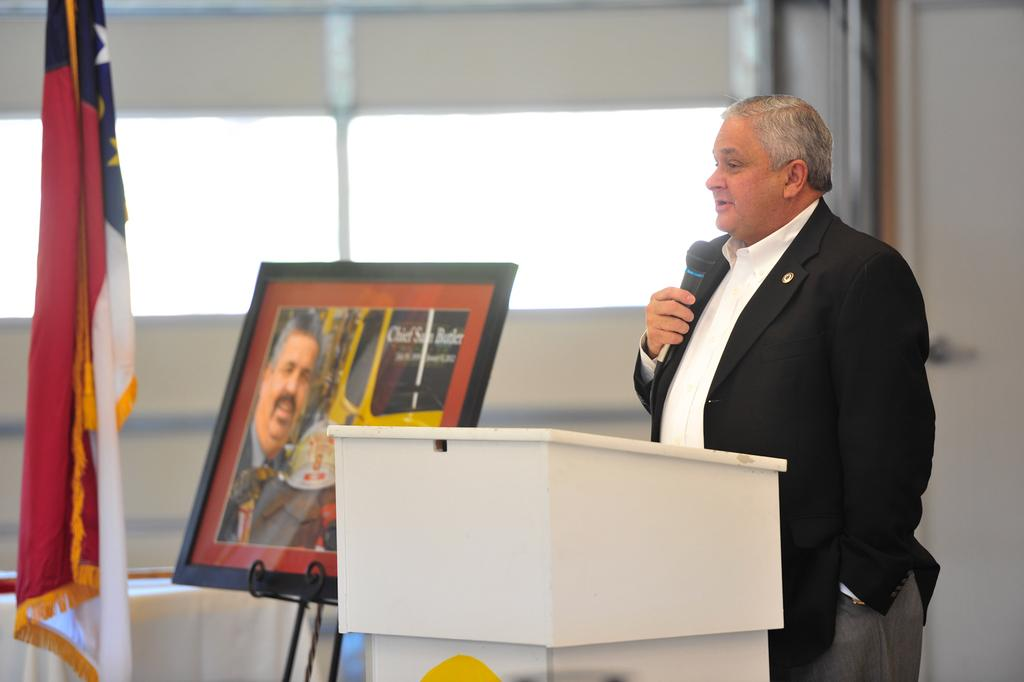Who is the main subject in the image? There is a man in the image. Where is the man located in the image? The man is on the right side of the image. What is the man doing in the image? The man is speaking into a microphone. What objects can be seen in the middle of the image? There is a photo frame and a podium in the middle of the image. What is on the left side of the image? There is cloth visible on the left side of the image. What direction is the man facing in the image? The direction the man is facing cannot be determined from the image. How many ladybugs are visible on the podium in the image? There are no ladybugs present in the image. What type of fruit is on the photo frame in the image? There is no fruit, including pears, present on the photo frame in the image. 